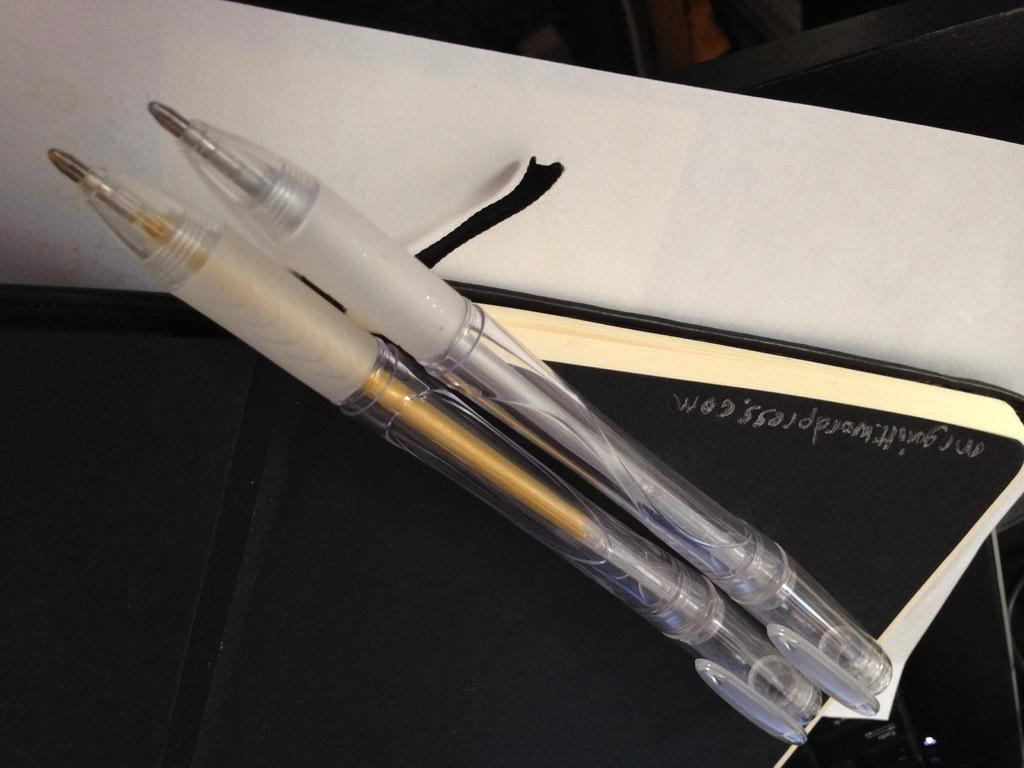How many pens can be seen in the image? There are two pens in the image. What is the book used for in the image? The book is likely used for reading or studying, as it is a common use for books. What is the paper used for in the image? The paper might be used for writing or drawing, as it is often used for these purposes. Can you describe the objects in the background of the image? Unfortunately, the provided facts do not give any information about the objects in the background of the image. How many crates are stacked in the background of the image? There are no crates present in the image. What type of turkey is depicted on the paper in the image? There is no turkey depicted on the paper in the image. 